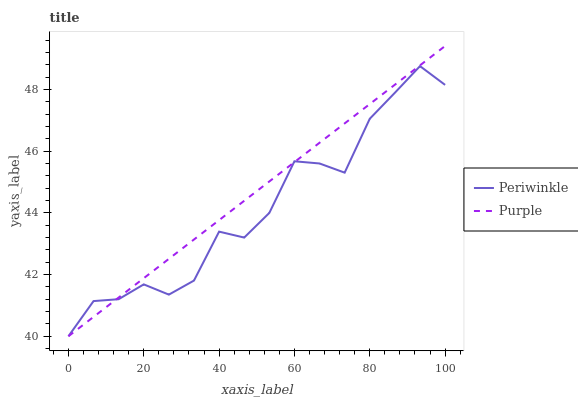Does Periwinkle have the minimum area under the curve?
Answer yes or no. Yes. Does Purple have the maximum area under the curve?
Answer yes or no. Yes. Does Periwinkle have the maximum area under the curve?
Answer yes or no. No. Is Purple the smoothest?
Answer yes or no. Yes. Is Periwinkle the roughest?
Answer yes or no. Yes. Is Periwinkle the smoothest?
Answer yes or no. No. Does Purple have the lowest value?
Answer yes or no. Yes. Does Purple have the highest value?
Answer yes or no. Yes. Does Periwinkle have the highest value?
Answer yes or no. No. Does Purple intersect Periwinkle?
Answer yes or no. Yes. Is Purple less than Periwinkle?
Answer yes or no. No. Is Purple greater than Periwinkle?
Answer yes or no. No. 